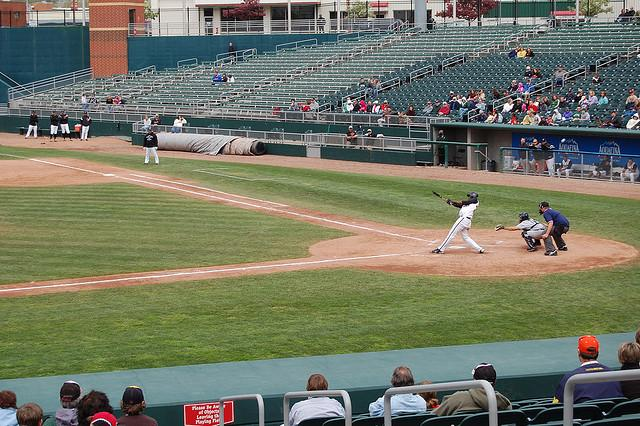How many players in baseball team?

Choices:
A) 12
B) 11
C) eight
D) nine nine 